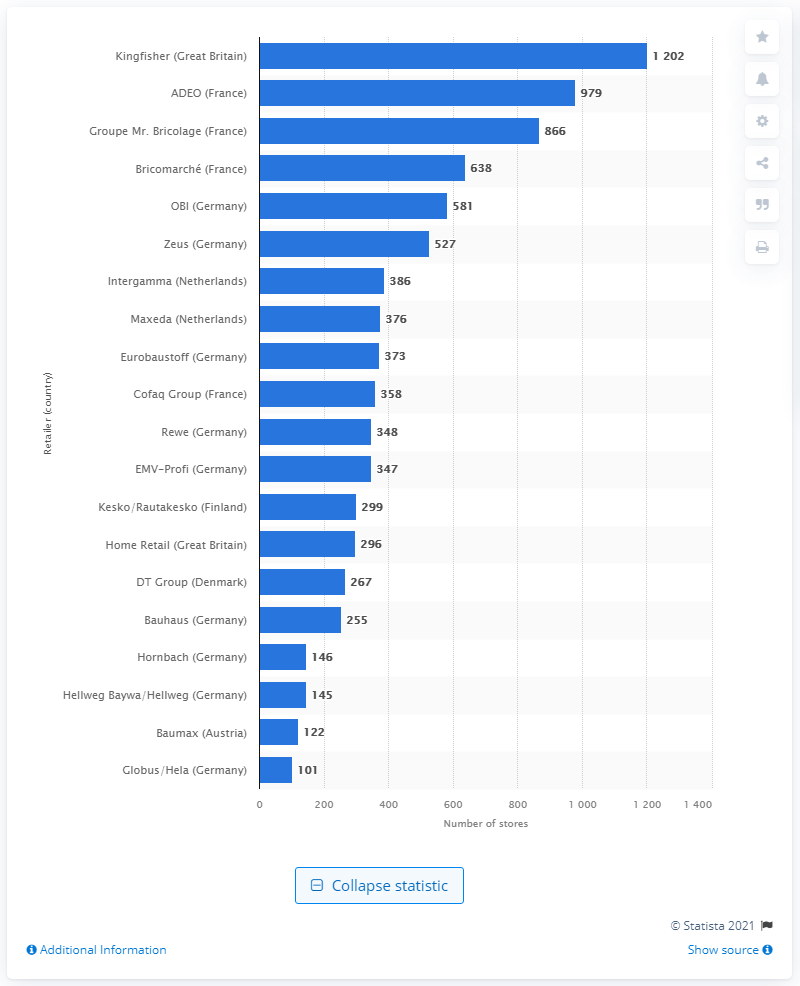Can you tell me about the growth or reduction of store numbers for any of these retailers? Without more recent data for comparison, I cannot provide specifics on the growth or reduction of store numbers. However, typically, such figures might reflect expansion or consolidation strategies in response to market trends and consumer demand. 